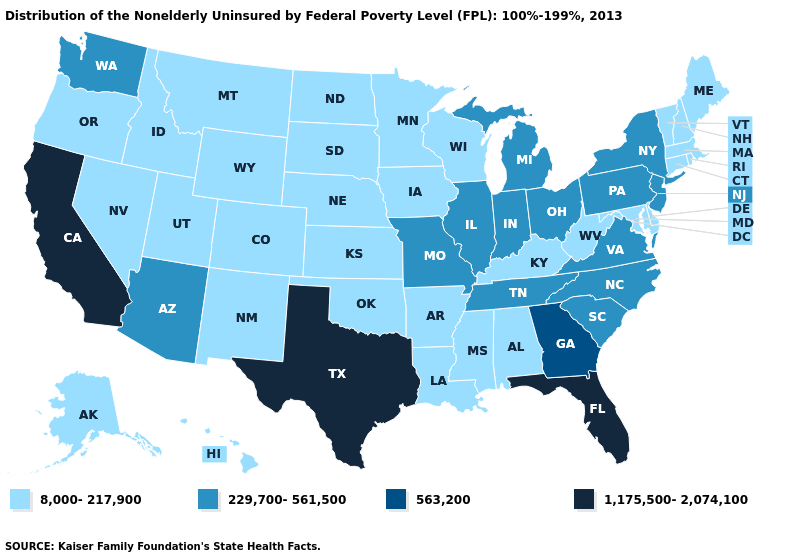What is the value of Delaware?
Keep it brief. 8,000-217,900. Which states have the lowest value in the Northeast?
Quick response, please. Connecticut, Maine, Massachusetts, New Hampshire, Rhode Island, Vermont. What is the value of New York?
Keep it brief. 229,700-561,500. What is the lowest value in states that border Mississippi?
Short answer required. 8,000-217,900. What is the highest value in the USA?
Answer briefly. 1,175,500-2,074,100. Does Missouri have the lowest value in the MidWest?
Give a very brief answer. No. Among the states that border Missouri , does Oklahoma have the lowest value?
Short answer required. Yes. What is the lowest value in states that border Maine?
Short answer required. 8,000-217,900. What is the value of Arizona?
Short answer required. 229,700-561,500. What is the lowest value in states that border Delaware?
Short answer required. 8,000-217,900. What is the value of Alabama?
Give a very brief answer. 8,000-217,900. Is the legend a continuous bar?
Be succinct. No. Name the states that have a value in the range 563,200?
Quick response, please. Georgia. What is the lowest value in the MidWest?
Write a very short answer. 8,000-217,900. Which states have the lowest value in the Northeast?
Be succinct. Connecticut, Maine, Massachusetts, New Hampshire, Rhode Island, Vermont. 